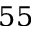<formula> <loc_0><loc_0><loc_500><loc_500>5 5</formula> 